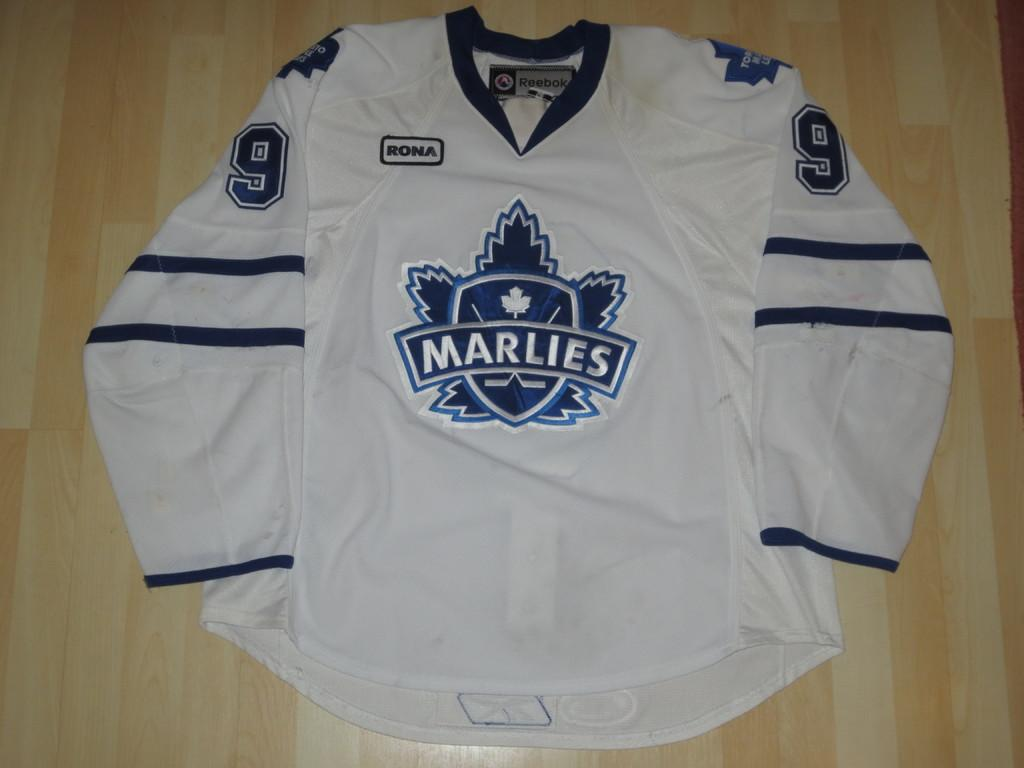<image>
Give a short and clear explanation of the subsequent image. a jersey that has the word Marlies on it 